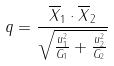Convert formula to latex. <formula><loc_0><loc_0><loc_500><loc_500>q = \frac { \overline { X } _ { 1 } \cdot \overline { X } _ { 2 } } { \sqrt { \frac { u _ { 1 } ^ { 2 } } { G _ { 1 } } + \frac { u _ { 2 } ^ { 2 } } { G _ { 2 } } } }</formula> 